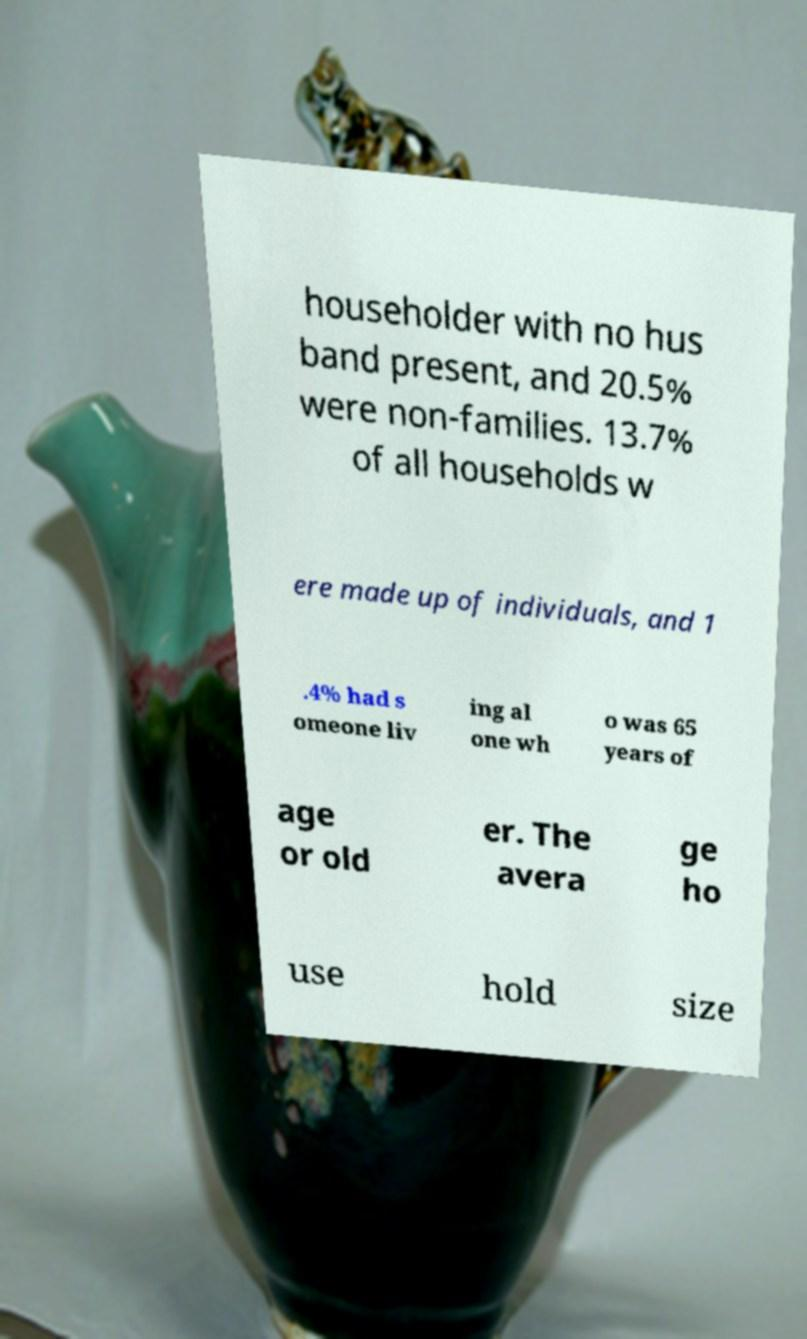I need the written content from this picture converted into text. Can you do that? householder with no hus band present, and 20.5% were non-families. 13.7% of all households w ere made up of individuals, and 1 .4% had s omeone liv ing al one wh o was 65 years of age or old er. The avera ge ho use hold size 